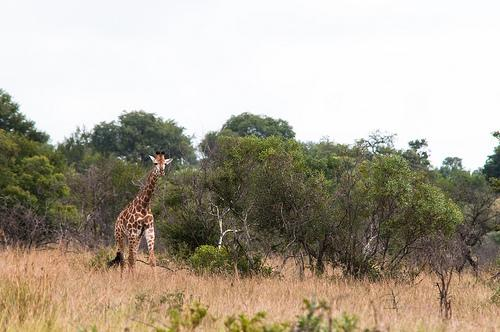Mention the main animal in the image and something unique about them. A very tall giraffe, with thick forethighs and two big black tufted-top horns, stands in a field surrounded by tall grass and trees. Describe the vegetation and landscape features in the image. The image features a variety of trees, mostly acacia, green and grey ones, small plants, weeds, and dry grass in a beautiful African savanna landscape. State the most striking feature of the giraffe in the image. The giraffe's unique brown and white skin patches make it a truly striking and remarkable creature in the picture. Provide a poetic description of the setting and the main creature featured in this image. Amidst the multitude of verdant trees and golden, sun-drenched savannah grass, a towering giraffe gracefully strides, showcasing its beautiful, patchwork coat. Describe the setting of this image and its atmosphere. The image shows an African savanna with a mix of green and dry grass, trees, and blue skies, creating a serene and peaceful atmosphere. Point out the main object in the photo and provide a detailed description of its appearance. The giraffe in the photo has brown and white skin patches, two fuzzy black horns, standard ears akimbo, and a long neck, making it quite a majestic creature. Provide a brief description of the primary scene captured in the image. A tall giraffe with brown and white patches is walking through a savannah with trees, grass, and blue skies in the background. Write a short description of the image focusing on the colors present. In this vibrant image, a giraffe with brown and white patches walks among the green grass and trees under the brilliant blue skies. Give a short description of the giraffe's behavior depicted in the image. The giraffe appears to be walking calmly across the field, surrounded by the tall grass and dense forest of the savanna. Mention the main species present in the image and their environment. The image features a giraffe among a diverse range of vegetation like acacia trees and tall grass in the African savanna. 